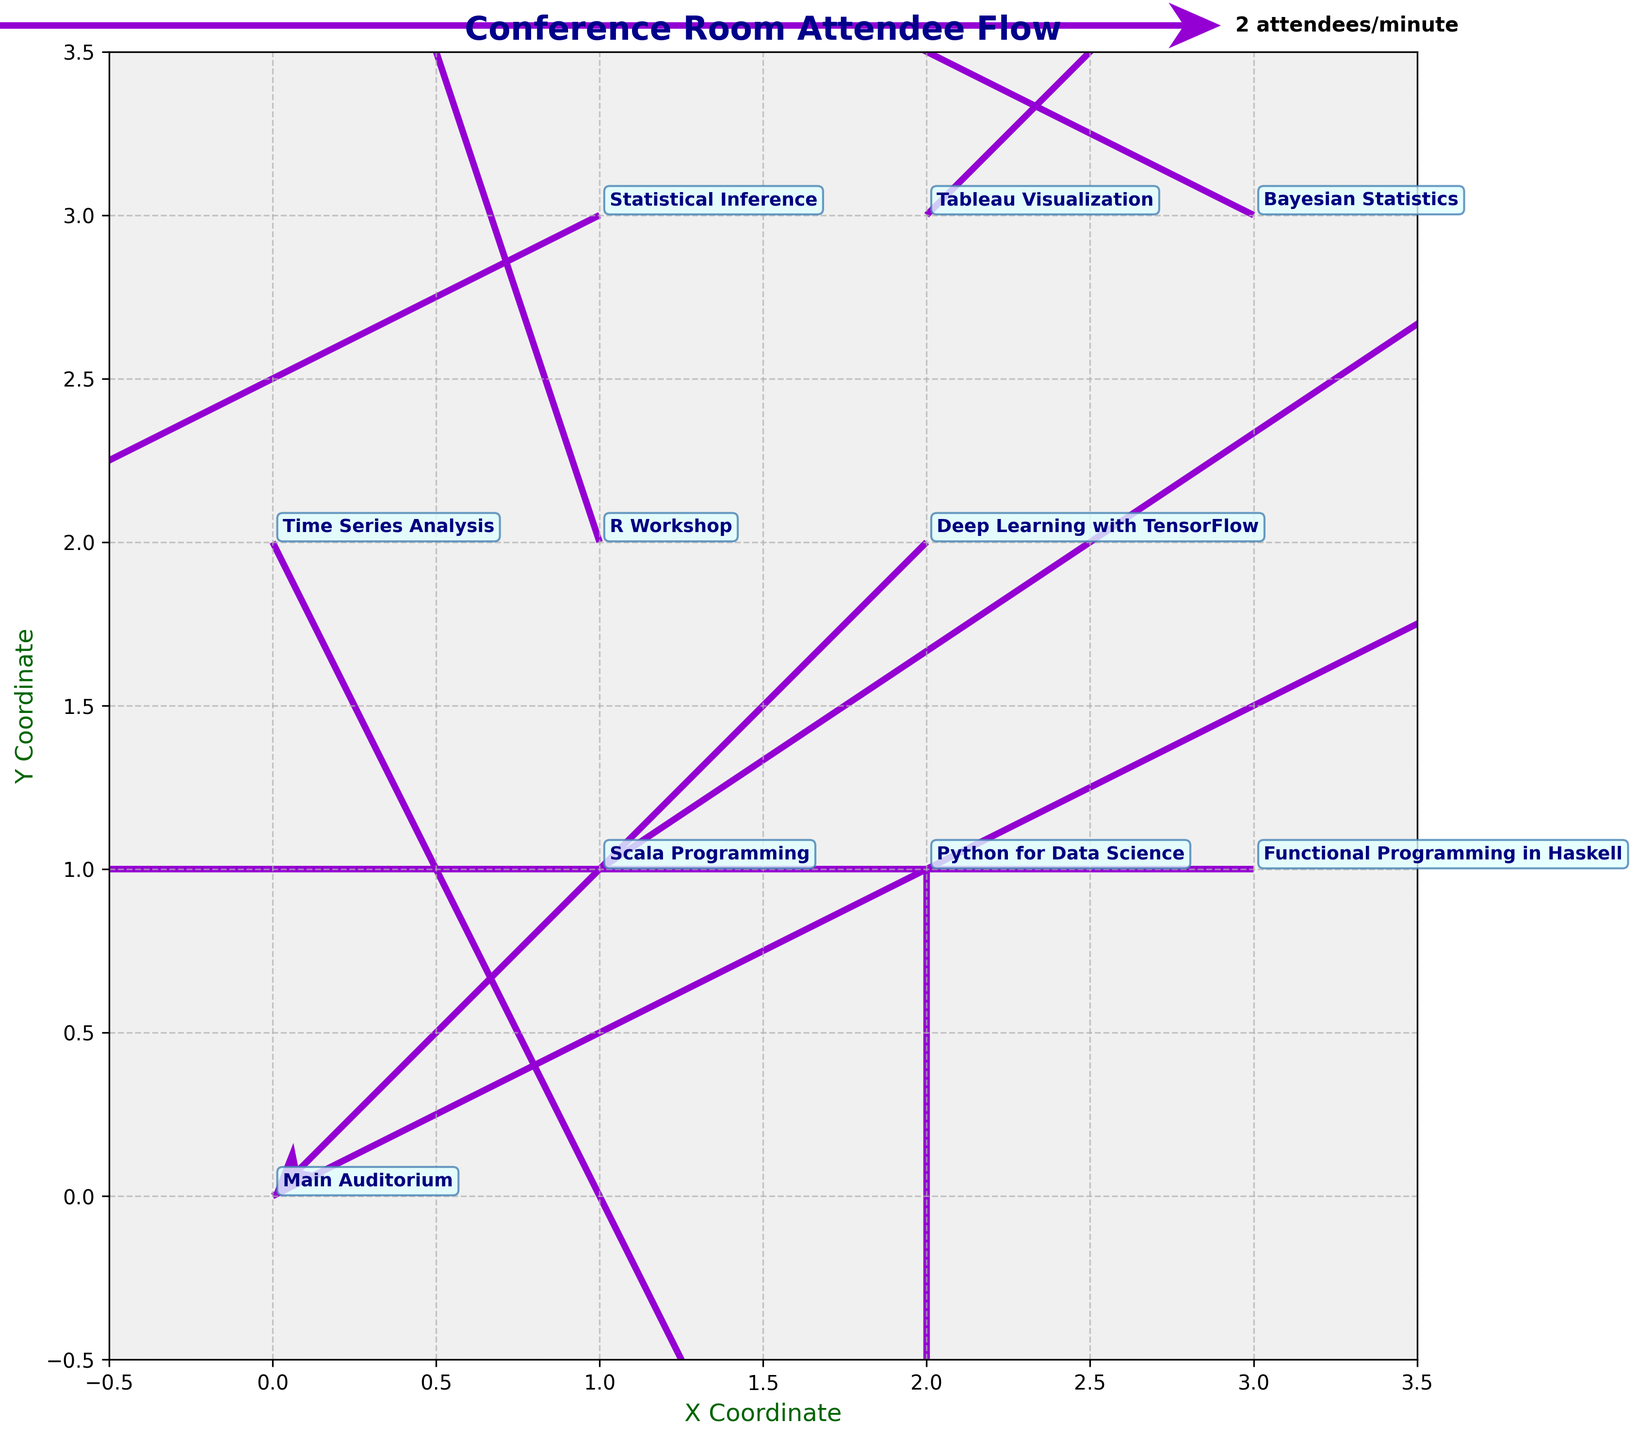How many rooms are present in the figure? There are 10 different room names annotated on the plot which indicate the number of rooms.
Answer: 10 What is the title of the figure? The title is displayed at the top center of the plot in bold font and dark blue color.
Answer: Conference Room Attendee Flow Which room shows attendees having the highest net movement towards it? We need to look for the room where the net vector sum of attendees is the highest. In this case, attendees mostly move towards "R Workshop" at location (1, 2) with vectors summing to (1,3).
Answer: R Workshop Are there any rooms where attendees are not moving to/from? We need to check if any rooms have both u and v values as zero. All rooms have at least one non-zero movement vector.
Answer: No Which room has the most negative movement along the x-axis? Look for the room with the most negative x-component in its vector. "Functional Programming in Haskell" at (3, 1) has the most negative x-movement of -3.
Answer: Functional Programming in Haskell What is the color used for the vectors in the figure? The vectors' color in the quiver plot is consistently dark violet.
Answer: dark violet Which room has the least movement towards the y-axis? Look at the smallest non-zero y-component. "Python for Data Science" at (2, 1) has the least y-movement with -2.
Answer: Python for Data Science Which rooms show a diagonal movement? Diagonal movements involve both x and y components being non-zero. "Main Auditorium," "R Workshop," "Bayesian Statistics," "Scala Programming," "Deep Learning with TensorFlow," "Time Series Analysis," "Statistical Inference," and "Tableau Visualization" exhibit such movements.
Answer: Main Auditorium, R Workshop, Bayesian Statistics, Scala Programming, Deep Learning with TensorFlow, Time Series Analysis, Statistical Inference, Tableau Visualization What is the range of the x and y coordinates on the plot? The x and y limits of the plot are set from -0.5 to 3.5 as displayed by the axis range on the plot.
Answer: -0.5 to 3.5 Do any rooms have only vertical or only horizontal movements? Check for rooms where either u or v is zero which indicates purely vertical or horizontal movement. "Python for Data Science" (u=0), "Deep Learning with TensorFlow" (u=-1, v=-1), "Functional Programming in Haskell" (v=0).
Answer: Python for Data Science, Deep Learning with TensorFlow, Functional Programming in Haskell 